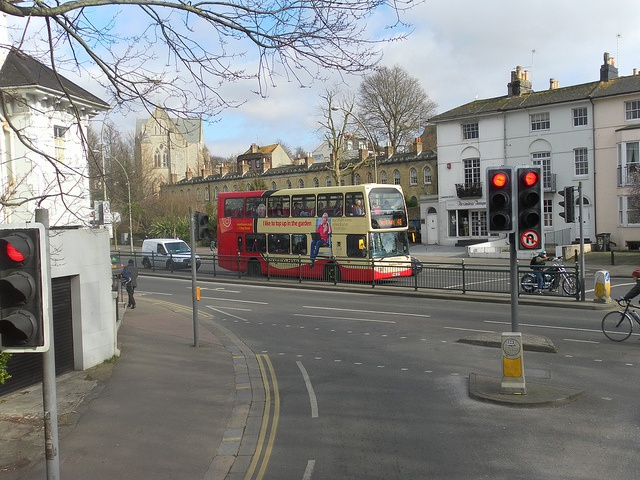Describe the objects in this image and their specific colors. I can see bus in gray, black, tan, and maroon tones, traffic light in gray, black, and lightgray tones, traffic light in gray, black, darkgray, and brown tones, traffic light in gray, black, and maroon tones, and truck in gray, black, darkgray, and lightgray tones in this image. 